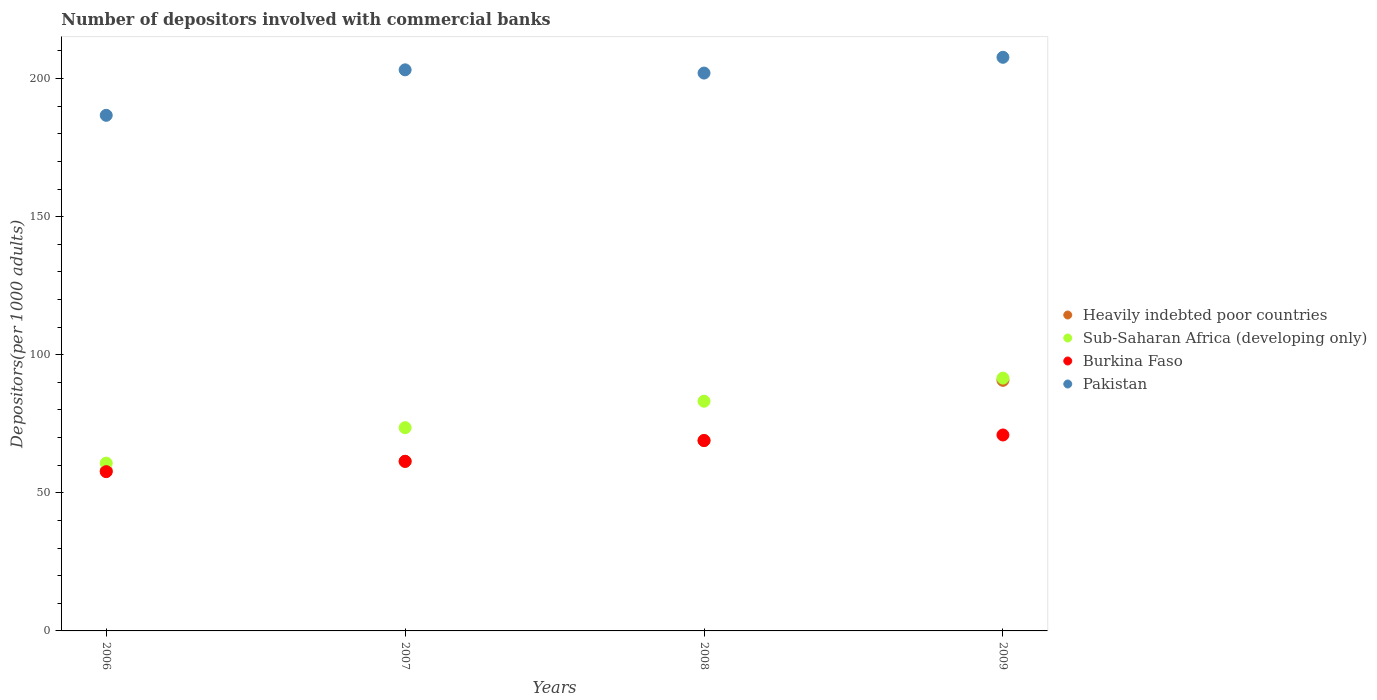What is the number of depositors involved with commercial banks in Burkina Faso in 2008?
Make the answer very short. 68.94. Across all years, what is the maximum number of depositors involved with commercial banks in Heavily indebted poor countries?
Provide a short and direct response. 90.74. Across all years, what is the minimum number of depositors involved with commercial banks in Heavily indebted poor countries?
Provide a succinct answer. 57.99. In which year was the number of depositors involved with commercial banks in Sub-Saharan Africa (developing only) maximum?
Offer a very short reply. 2009. What is the total number of depositors involved with commercial banks in Burkina Faso in the graph?
Offer a terse response. 258.97. What is the difference between the number of depositors involved with commercial banks in Burkina Faso in 2006 and that in 2009?
Make the answer very short. -13.29. What is the difference between the number of depositors involved with commercial banks in Pakistan in 2007 and the number of depositors involved with commercial banks in Heavily indebted poor countries in 2008?
Give a very brief answer. 134.23. What is the average number of depositors involved with commercial banks in Heavily indebted poor countries per year?
Give a very brief answer. 69.77. In the year 2007, what is the difference between the number of depositors involved with commercial banks in Pakistan and number of depositors involved with commercial banks in Heavily indebted poor countries?
Provide a short and direct response. 141.76. What is the ratio of the number of depositors involved with commercial banks in Heavily indebted poor countries in 2006 to that in 2009?
Make the answer very short. 0.64. Is the number of depositors involved with commercial banks in Pakistan in 2006 less than that in 2008?
Ensure brevity in your answer.  Yes. What is the difference between the highest and the second highest number of depositors involved with commercial banks in Sub-Saharan Africa (developing only)?
Ensure brevity in your answer.  8.37. What is the difference between the highest and the lowest number of depositors involved with commercial banks in Pakistan?
Keep it short and to the point. 21.01. In how many years, is the number of depositors involved with commercial banks in Pakistan greater than the average number of depositors involved with commercial banks in Pakistan taken over all years?
Provide a succinct answer. 3. Is the sum of the number of depositors involved with commercial banks in Heavily indebted poor countries in 2008 and 2009 greater than the maximum number of depositors involved with commercial banks in Pakistan across all years?
Your answer should be compact. No. Is it the case that in every year, the sum of the number of depositors involved with commercial banks in Heavily indebted poor countries and number of depositors involved with commercial banks in Sub-Saharan Africa (developing only)  is greater than the sum of number of depositors involved with commercial banks in Pakistan and number of depositors involved with commercial banks in Burkina Faso?
Offer a very short reply. No. Is it the case that in every year, the sum of the number of depositors involved with commercial banks in Sub-Saharan Africa (developing only) and number of depositors involved with commercial banks in Pakistan  is greater than the number of depositors involved with commercial banks in Heavily indebted poor countries?
Give a very brief answer. Yes. Does the number of depositors involved with commercial banks in Pakistan monotonically increase over the years?
Provide a succinct answer. No. Is the number of depositors involved with commercial banks in Heavily indebted poor countries strictly greater than the number of depositors involved with commercial banks in Burkina Faso over the years?
Give a very brief answer. No. How many dotlines are there?
Your response must be concise. 4. What is the difference between two consecutive major ticks on the Y-axis?
Provide a short and direct response. 50. Does the graph contain any zero values?
Provide a short and direct response. No. What is the title of the graph?
Offer a very short reply. Number of depositors involved with commercial banks. What is the label or title of the Y-axis?
Keep it short and to the point. Depositors(per 1000 adults). What is the Depositors(per 1000 adults) in Heavily indebted poor countries in 2006?
Give a very brief answer. 57.99. What is the Depositors(per 1000 adults) of Sub-Saharan Africa (developing only) in 2006?
Provide a short and direct response. 60.76. What is the Depositors(per 1000 adults) in Burkina Faso in 2006?
Provide a short and direct response. 57.67. What is the Depositors(per 1000 adults) of Pakistan in 2006?
Offer a very short reply. 186.7. What is the Depositors(per 1000 adults) of Heavily indebted poor countries in 2007?
Your response must be concise. 61.41. What is the Depositors(per 1000 adults) in Sub-Saharan Africa (developing only) in 2007?
Your answer should be compact. 73.6. What is the Depositors(per 1000 adults) of Burkina Faso in 2007?
Keep it short and to the point. 61.41. What is the Depositors(per 1000 adults) in Pakistan in 2007?
Provide a short and direct response. 203.17. What is the Depositors(per 1000 adults) of Heavily indebted poor countries in 2008?
Make the answer very short. 68.94. What is the Depositors(per 1000 adults) in Sub-Saharan Africa (developing only) in 2008?
Your response must be concise. 83.18. What is the Depositors(per 1000 adults) of Burkina Faso in 2008?
Your answer should be very brief. 68.94. What is the Depositors(per 1000 adults) in Pakistan in 2008?
Offer a very short reply. 202. What is the Depositors(per 1000 adults) in Heavily indebted poor countries in 2009?
Offer a very short reply. 90.74. What is the Depositors(per 1000 adults) of Sub-Saharan Africa (developing only) in 2009?
Ensure brevity in your answer.  91.54. What is the Depositors(per 1000 adults) in Burkina Faso in 2009?
Provide a short and direct response. 70.95. What is the Depositors(per 1000 adults) of Pakistan in 2009?
Keep it short and to the point. 207.71. Across all years, what is the maximum Depositors(per 1000 adults) in Heavily indebted poor countries?
Make the answer very short. 90.74. Across all years, what is the maximum Depositors(per 1000 adults) of Sub-Saharan Africa (developing only)?
Provide a short and direct response. 91.54. Across all years, what is the maximum Depositors(per 1000 adults) in Burkina Faso?
Provide a short and direct response. 70.95. Across all years, what is the maximum Depositors(per 1000 adults) of Pakistan?
Your answer should be very brief. 207.71. Across all years, what is the minimum Depositors(per 1000 adults) of Heavily indebted poor countries?
Your answer should be very brief. 57.99. Across all years, what is the minimum Depositors(per 1000 adults) of Sub-Saharan Africa (developing only)?
Offer a very short reply. 60.76. Across all years, what is the minimum Depositors(per 1000 adults) in Burkina Faso?
Provide a short and direct response. 57.67. Across all years, what is the minimum Depositors(per 1000 adults) in Pakistan?
Your answer should be very brief. 186.7. What is the total Depositors(per 1000 adults) in Heavily indebted poor countries in the graph?
Keep it short and to the point. 279.08. What is the total Depositors(per 1000 adults) in Sub-Saharan Africa (developing only) in the graph?
Provide a succinct answer. 309.08. What is the total Depositors(per 1000 adults) in Burkina Faso in the graph?
Make the answer very short. 258.97. What is the total Depositors(per 1000 adults) of Pakistan in the graph?
Make the answer very short. 799.58. What is the difference between the Depositors(per 1000 adults) of Heavily indebted poor countries in 2006 and that in 2007?
Provide a short and direct response. -3.42. What is the difference between the Depositors(per 1000 adults) of Sub-Saharan Africa (developing only) in 2006 and that in 2007?
Keep it short and to the point. -12.83. What is the difference between the Depositors(per 1000 adults) in Burkina Faso in 2006 and that in 2007?
Make the answer very short. -3.74. What is the difference between the Depositors(per 1000 adults) of Pakistan in 2006 and that in 2007?
Give a very brief answer. -16.47. What is the difference between the Depositors(per 1000 adults) in Heavily indebted poor countries in 2006 and that in 2008?
Provide a short and direct response. -10.95. What is the difference between the Depositors(per 1000 adults) in Sub-Saharan Africa (developing only) in 2006 and that in 2008?
Offer a very short reply. -22.41. What is the difference between the Depositors(per 1000 adults) in Burkina Faso in 2006 and that in 2008?
Ensure brevity in your answer.  -11.27. What is the difference between the Depositors(per 1000 adults) of Pakistan in 2006 and that in 2008?
Provide a short and direct response. -15.3. What is the difference between the Depositors(per 1000 adults) of Heavily indebted poor countries in 2006 and that in 2009?
Provide a short and direct response. -32.75. What is the difference between the Depositors(per 1000 adults) of Sub-Saharan Africa (developing only) in 2006 and that in 2009?
Your answer should be compact. -30.78. What is the difference between the Depositors(per 1000 adults) of Burkina Faso in 2006 and that in 2009?
Make the answer very short. -13.29. What is the difference between the Depositors(per 1000 adults) of Pakistan in 2006 and that in 2009?
Provide a succinct answer. -21.01. What is the difference between the Depositors(per 1000 adults) in Heavily indebted poor countries in 2007 and that in 2008?
Your answer should be very brief. -7.53. What is the difference between the Depositors(per 1000 adults) of Sub-Saharan Africa (developing only) in 2007 and that in 2008?
Give a very brief answer. -9.58. What is the difference between the Depositors(per 1000 adults) in Burkina Faso in 2007 and that in 2008?
Offer a terse response. -7.53. What is the difference between the Depositors(per 1000 adults) of Pakistan in 2007 and that in 2008?
Offer a terse response. 1.17. What is the difference between the Depositors(per 1000 adults) of Heavily indebted poor countries in 2007 and that in 2009?
Provide a short and direct response. -29.33. What is the difference between the Depositors(per 1000 adults) in Sub-Saharan Africa (developing only) in 2007 and that in 2009?
Ensure brevity in your answer.  -17.95. What is the difference between the Depositors(per 1000 adults) in Burkina Faso in 2007 and that in 2009?
Offer a very short reply. -9.54. What is the difference between the Depositors(per 1000 adults) in Pakistan in 2007 and that in 2009?
Provide a short and direct response. -4.54. What is the difference between the Depositors(per 1000 adults) of Heavily indebted poor countries in 2008 and that in 2009?
Keep it short and to the point. -21.8. What is the difference between the Depositors(per 1000 adults) in Sub-Saharan Africa (developing only) in 2008 and that in 2009?
Offer a terse response. -8.37. What is the difference between the Depositors(per 1000 adults) of Burkina Faso in 2008 and that in 2009?
Ensure brevity in your answer.  -2.01. What is the difference between the Depositors(per 1000 adults) in Pakistan in 2008 and that in 2009?
Provide a succinct answer. -5.71. What is the difference between the Depositors(per 1000 adults) of Heavily indebted poor countries in 2006 and the Depositors(per 1000 adults) of Sub-Saharan Africa (developing only) in 2007?
Offer a terse response. -15.61. What is the difference between the Depositors(per 1000 adults) of Heavily indebted poor countries in 2006 and the Depositors(per 1000 adults) of Burkina Faso in 2007?
Provide a short and direct response. -3.42. What is the difference between the Depositors(per 1000 adults) of Heavily indebted poor countries in 2006 and the Depositors(per 1000 adults) of Pakistan in 2007?
Ensure brevity in your answer.  -145.18. What is the difference between the Depositors(per 1000 adults) in Sub-Saharan Africa (developing only) in 2006 and the Depositors(per 1000 adults) in Burkina Faso in 2007?
Ensure brevity in your answer.  -0.65. What is the difference between the Depositors(per 1000 adults) of Sub-Saharan Africa (developing only) in 2006 and the Depositors(per 1000 adults) of Pakistan in 2007?
Offer a very short reply. -142.41. What is the difference between the Depositors(per 1000 adults) in Burkina Faso in 2006 and the Depositors(per 1000 adults) in Pakistan in 2007?
Your answer should be very brief. -145.5. What is the difference between the Depositors(per 1000 adults) in Heavily indebted poor countries in 2006 and the Depositors(per 1000 adults) in Sub-Saharan Africa (developing only) in 2008?
Offer a terse response. -25.19. What is the difference between the Depositors(per 1000 adults) of Heavily indebted poor countries in 2006 and the Depositors(per 1000 adults) of Burkina Faso in 2008?
Your answer should be compact. -10.95. What is the difference between the Depositors(per 1000 adults) of Heavily indebted poor countries in 2006 and the Depositors(per 1000 adults) of Pakistan in 2008?
Provide a short and direct response. -144.01. What is the difference between the Depositors(per 1000 adults) in Sub-Saharan Africa (developing only) in 2006 and the Depositors(per 1000 adults) in Burkina Faso in 2008?
Provide a succinct answer. -8.18. What is the difference between the Depositors(per 1000 adults) of Sub-Saharan Africa (developing only) in 2006 and the Depositors(per 1000 adults) of Pakistan in 2008?
Give a very brief answer. -141.24. What is the difference between the Depositors(per 1000 adults) in Burkina Faso in 2006 and the Depositors(per 1000 adults) in Pakistan in 2008?
Provide a short and direct response. -144.33. What is the difference between the Depositors(per 1000 adults) in Heavily indebted poor countries in 2006 and the Depositors(per 1000 adults) in Sub-Saharan Africa (developing only) in 2009?
Offer a very short reply. -33.55. What is the difference between the Depositors(per 1000 adults) in Heavily indebted poor countries in 2006 and the Depositors(per 1000 adults) in Burkina Faso in 2009?
Your answer should be compact. -12.96. What is the difference between the Depositors(per 1000 adults) in Heavily indebted poor countries in 2006 and the Depositors(per 1000 adults) in Pakistan in 2009?
Offer a very short reply. -149.72. What is the difference between the Depositors(per 1000 adults) in Sub-Saharan Africa (developing only) in 2006 and the Depositors(per 1000 adults) in Burkina Faso in 2009?
Your answer should be compact. -10.19. What is the difference between the Depositors(per 1000 adults) in Sub-Saharan Africa (developing only) in 2006 and the Depositors(per 1000 adults) in Pakistan in 2009?
Ensure brevity in your answer.  -146.95. What is the difference between the Depositors(per 1000 adults) in Burkina Faso in 2006 and the Depositors(per 1000 adults) in Pakistan in 2009?
Your answer should be compact. -150.04. What is the difference between the Depositors(per 1000 adults) of Heavily indebted poor countries in 2007 and the Depositors(per 1000 adults) of Sub-Saharan Africa (developing only) in 2008?
Make the answer very short. -21.77. What is the difference between the Depositors(per 1000 adults) of Heavily indebted poor countries in 2007 and the Depositors(per 1000 adults) of Burkina Faso in 2008?
Provide a short and direct response. -7.53. What is the difference between the Depositors(per 1000 adults) in Heavily indebted poor countries in 2007 and the Depositors(per 1000 adults) in Pakistan in 2008?
Your response must be concise. -140.59. What is the difference between the Depositors(per 1000 adults) of Sub-Saharan Africa (developing only) in 2007 and the Depositors(per 1000 adults) of Burkina Faso in 2008?
Ensure brevity in your answer.  4.66. What is the difference between the Depositors(per 1000 adults) of Sub-Saharan Africa (developing only) in 2007 and the Depositors(per 1000 adults) of Pakistan in 2008?
Offer a terse response. -128.4. What is the difference between the Depositors(per 1000 adults) of Burkina Faso in 2007 and the Depositors(per 1000 adults) of Pakistan in 2008?
Make the answer very short. -140.59. What is the difference between the Depositors(per 1000 adults) in Heavily indebted poor countries in 2007 and the Depositors(per 1000 adults) in Sub-Saharan Africa (developing only) in 2009?
Offer a very short reply. -30.13. What is the difference between the Depositors(per 1000 adults) of Heavily indebted poor countries in 2007 and the Depositors(per 1000 adults) of Burkina Faso in 2009?
Provide a short and direct response. -9.54. What is the difference between the Depositors(per 1000 adults) of Heavily indebted poor countries in 2007 and the Depositors(per 1000 adults) of Pakistan in 2009?
Your answer should be compact. -146.3. What is the difference between the Depositors(per 1000 adults) in Sub-Saharan Africa (developing only) in 2007 and the Depositors(per 1000 adults) in Burkina Faso in 2009?
Make the answer very short. 2.64. What is the difference between the Depositors(per 1000 adults) in Sub-Saharan Africa (developing only) in 2007 and the Depositors(per 1000 adults) in Pakistan in 2009?
Make the answer very short. -134.11. What is the difference between the Depositors(per 1000 adults) in Burkina Faso in 2007 and the Depositors(per 1000 adults) in Pakistan in 2009?
Keep it short and to the point. -146.3. What is the difference between the Depositors(per 1000 adults) in Heavily indebted poor countries in 2008 and the Depositors(per 1000 adults) in Sub-Saharan Africa (developing only) in 2009?
Your answer should be very brief. -22.6. What is the difference between the Depositors(per 1000 adults) in Heavily indebted poor countries in 2008 and the Depositors(per 1000 adults) in Burkina Faso in 2009?
Provide a succinct answer. -2.01. What is the difference between the Depositors(per 1000 adults) of Heavily indebted poor countries in 2008 and the Depositors(per 1000 adults) of Pakistan in 2009?
Keep it short and to the point. -138.77. What is the difference between the Depositors(per 1000 adults) in Sub-Saharan Africa (developing only) in 2008 and the Depositors(per 1000 adults) in Burkina Faso in 2009?
Offer a terse response. 12.22. What is the difference between the Depositors(per 1000 adults) of Sub-Saharan Africa (developing only) in 2008 and the Depositors(per 1000 adults) of Pakistan in 2009?
Your answer should be very brief. -124.53. What is the difference between the Depositors(per 1000 adults) of Burkina Faso in 2008 and the Depositors(per 1000 adults) of Pakistan in 2009?
Make the answer very short. -138.77. What is the average Depositors(per 1000 adults) of Heavily indebted poor countries per year?
Ensure brevity in your answer.  69.77. What is the average Depositors(per 1000 adults) in Sub-Saharan Africa (developing only) per year?
Ensure brevity in your answer.  77.27. What is the average Depositors(per 1000 adults) in Burkina Faso per year?
Your answer should be compact. 64.74. What is the average Depositors(per 1000 adults) of Pakistan per year?
Offer a very short reply. 199.9. In the year 2006, what is the difference between the Depositors(per 1000 adults) in Heavily indebted poor countries and Depositors(per 1000 adults) in Sub-Saharan Africa (developing only)?
Make the answer very short. -2.77. In the year 2006, what is the difference between the Depositors(per 1000 adults) of Heavily indebted poor countries and Depositors(per 1000 adults) of Burkina Faso?
Provide a short and direct response. 0.32. In the year 2006, what is the difference between the Depositors(per 1000 adults) of Heavily indebted poor countries and Depositors(per 1000 adults) of Pakistan?
Offer a terse response. -128.71. In the year 2006, what is the difference between the Depositors(per 1000 adults) in Sub-Saharan Africa (developing only) and Depositors(per 1000 adults) in Burkina Faso?
Offer a very short reply. 3.1. In the year 2006, what is the difference between the Depositors(per 1000 adults) in Sub-Saharan Africa (developing only) and Depositors(per 1000 adults) in Pakistan?
Your response must be concise. -125.94. In the year 2006, what is the difference between the Depositors(per 1000 adults) of Burkina Faso and Depositors(per 1000 adults) of Pakistan?
Your response must be concise. -129.04. In the year 2007, what is the difference between the Depositors(per 1000 adults) of Heavily indebted poor countries and Depositors(per 1000 adults) of Sub-Saharan Africa (developing only)?
Offer a terse response. -12.19. In the year 2007, what is the difference between the Depositors(per 1000 adults) of Heavily indebted poor countries and Depositors(per 1000 adults) of Burkina Faso?
Your answer should be compact. 0. In the year 2007, what is the difference between the Depositors(per 1000 adults) of Heavily indebted poor countries and Depositors(per 1000 adults) of Pakistan?
Ensure brevity in your answer.  -141.76. In the year 2007, what is the difference between the Depositors(per 1000 adults) of Sub-Saharan Africa (developing only) and Depositors(per 1000 adults) of Burkina Faso?
Your answer should be very brief. 12.19. In the year 2007, what is the difference between the Depositors(per 1000 adults) of Sub-Saharan Africa (developing only) and Depositors(per 1000 adults) of Pakistan?
Your response must be concise. -129.57. In the year 2007, what is the difference between the Depositors(per 1000 adults) in Burkina Faso and Depositors(per 1000 adults) in Pakistan?
Your response must be concise. -141.76. In the year 2008, what is the difference between the Depositors(per 1000 adults) of Heavily indebted poor countries and Depositors(per 1000 adults) of Sub-Saharan Africa (developing only)?
Keep it short and to the point. -14.24. In the year 2008, what is the difference between the Depositors(per 1000 adults) of Heavily indebted poor countries and Depositors(per 1000 adults) of Pakistan?
Give a very brief answer. -133.06. In the year 2008, what is the difference between the Depositors(per 1000 adults) in Sub-Saharan Africa (developing only) and Depositors(per 1000 adults) in Burkina Faso?
Keep it short and to the point. 14.24. In the year 2008, what is the difference between the Depositors(per 1000 adults) of Sub-Saharan Africa (developing only) and Depositors(per 1000 adults) of Pakistan?
Your answer should be very brief. -118.82. In the year 2008, what is the difference between the Depositors(per 1000 adults) in Burkina Faso and Depositors(per 1000 adults) in Pakistan?
Provide a succinct answer. -133.06. In the year 2009, what is the difference between the Depositors(per 1000 adults) of Heavily indebted poor countries and Depositors(per 1000 adults) of Sub-Saharan Africa (developing only)?
Make the answer very short. -0.8. In the year 2009, what is the difference between the Depositors(per 1000 adults) of Heavily indebted poor countries and Depositors(per 1000 adults) of Burkina Faso?
Offer a very short reply. 19.79. In the year 2009, what is the difference between the Depositors(per 1000 adults) in Heavily indebted poor countries and Depositors(per 1000 adults) in Pakistan?
Your answer should be compact. -116.97. In the year 2009, what is the difference between the Depositors(per 1000 adults) in Sub-Saharan Africa (developing only) and Depositors(per 1000 adults) in Burkina Faso?
Make the answer very short. 20.59. In the year 2009, what is the difference between the Depositors(per 1000 adults) in Sub-Saharan Africa (developing only) and Depositors(per 1000 adults) in Pakistan?
Your answer should be very brief. -116.17. In the year 2009, what is the difference between the Depositors(per 1000 adults) of Burkina Faso and Depositors(per 1000 adults) of Pakistan?
Offer a very short reply. -136.76. What is the ratio of the Depositors(per 1000 adults) in Heavily indebted poor countries in 2006 to that in 2007?
Your answer should be very brief. 0.94. What is the ratio of the Depositors(per 1000 adults) in Sub-Saharan Africa (developing only) in 2006 to that in 2007?
Offer a very short reply. 0.83. What is the ratio of the Depositors(per 1000 adults) of Burkina Faso in 2006 to that in 2007?
Offer a very short reply. 0.94. What is the ratio of the Depositors(per 1000 adults) of Pakistan in 2006 to that in 2007?
Make the answer very short. 0.92. What is the ratio of the Depositors(per 1000 adults) in Heavily indebted poor countries in 2006 to that in 2008?
Ensure brevity in your answer.  0.84. What is the ratio of the Depositors(per 1000 adults) of Sub-Saharan Africa (developing only) in 2006 to that in 2008?
Provide a short and direct response. 0.73. What is the ratio of the Depositors(per 1000 adults) of Burkina Faso in 2006 to that in 2008?
Provide a succinct answer. 0.84. What is the ratio of the Depositors(per 1000 adults) of Pakistan in 2006 to that in 2008?
Make the answer very short. 0.92. What is the ratio of the Depositors(per 1000 adults) in Heavily indebted poor countries in 2006 to that in 2009?
Your response must be concise. 0.64. What is the ratio of the Depositors(per 1000 adults) of Sub-Saharan Africa (developing only) in 2006 to that in 2009?
Provide a short and direct response. 0.66. What is the ratio of the Depositors(per 1000 adults) of Burkina Faso in 2006 to that in 2009?
Ensure brevity in your answer.  0.81. What is the ratio of the Depositors(per 1000 adults) of Pakistan in 2006 to that in 2009?
Your answer should be very brief. 0.9. What is the ratio of the Depositors(per 1000 adults) of Heavily indebted poor countries in 2007 to that in 2008?
Offer a terse response. 0.89. What is the ratio of the Depositors(per 1000 adults) of Sub-Saharan Africa (developing only) in 2007 to that in 2008?
Your answer should be compact. 0.88. What is the ratio of the Depositors(per 1000 adults) in Burkina Faso in 2007 to that in 2008?
Give a very brief answer. 0.89. What is the ratio of the Depositors(per 1000 adults) in Heavily indebted poor countries in 2007 to that in 2009?
Provide a succinct answer. 0.68. What is the ratio of the Depositors(per 1000 adults) in Sub-Saharan Africa (developing only) in 2007 to that in 2009?
Your answer should be very brief. 0.8. What is the ratio of the Depositors(per 1000 adults) of Burkina Faso in 2007 to that in 2009?
Your answer should be very brief. 0.87. What is the ratio of the Depositors(per 1000 adults) of Pakistan in 2007 to that in 2009?
Provide a succinct answer. 0.98. What is the ratio of the Depositors(per 1000 adults) in Heavily indebted poor countries in 2008 to that in 2009?
Give a very brief answer. 0.76. What is the ratio of the Depositors(per 1000 adults) of Sub-Saharan Africa (developing only) in 2008 to that in 2009?
Your response must be concise. 0.91. What is the ratio of the Depositors(per 1000 adults) of Burkina Faso in 2008 to that in 2009?
Keep it short and to the point. 0.97. What is the ratio of the Depositors(per 1000 adults) of Pakistan in 2008 to that in 2009?
Ensure brevity in your answer.  0.97. What is the difference between the highest and the second highest Depositors(per 1000 adults) in Heavily indebted poor countries?
Give a very brief answer. 21.8. What is the difference between the highest and the second highest Depositors(per 1000 adults) in Sub-Saharan Africa (developing only)?
Your answer should be compact. 8.37. What is the difference between the highest and the second highest Depositors(per 1000 adults) in Burkina Faso?
Your answer should be compact. 2.01. What is the difference between the highest and the second highest Depositors(per 1000 adults) in Pakistan?
Offer a very short reply. 4.54. What is the difference between the highest and the lowest Depositors(per 1000 adults) in Heavily indebted poor countries?
Offer a terse response. 32.75. What is the difference between the highest and the lowest Depositors(per 1000 adults) of Sub-Saharan Africa (developing only)?
Offer a very short reply. 30.78. What is the difference between the highest and the lowest Depositors(per 1000 adults) of Burkina Faso?
Your response must be concise. 13.29. What is the difference between the highest and the lowest Depositors(per 1000 adults) of Pakistan?
Your answer should be very brief. 21.01. 